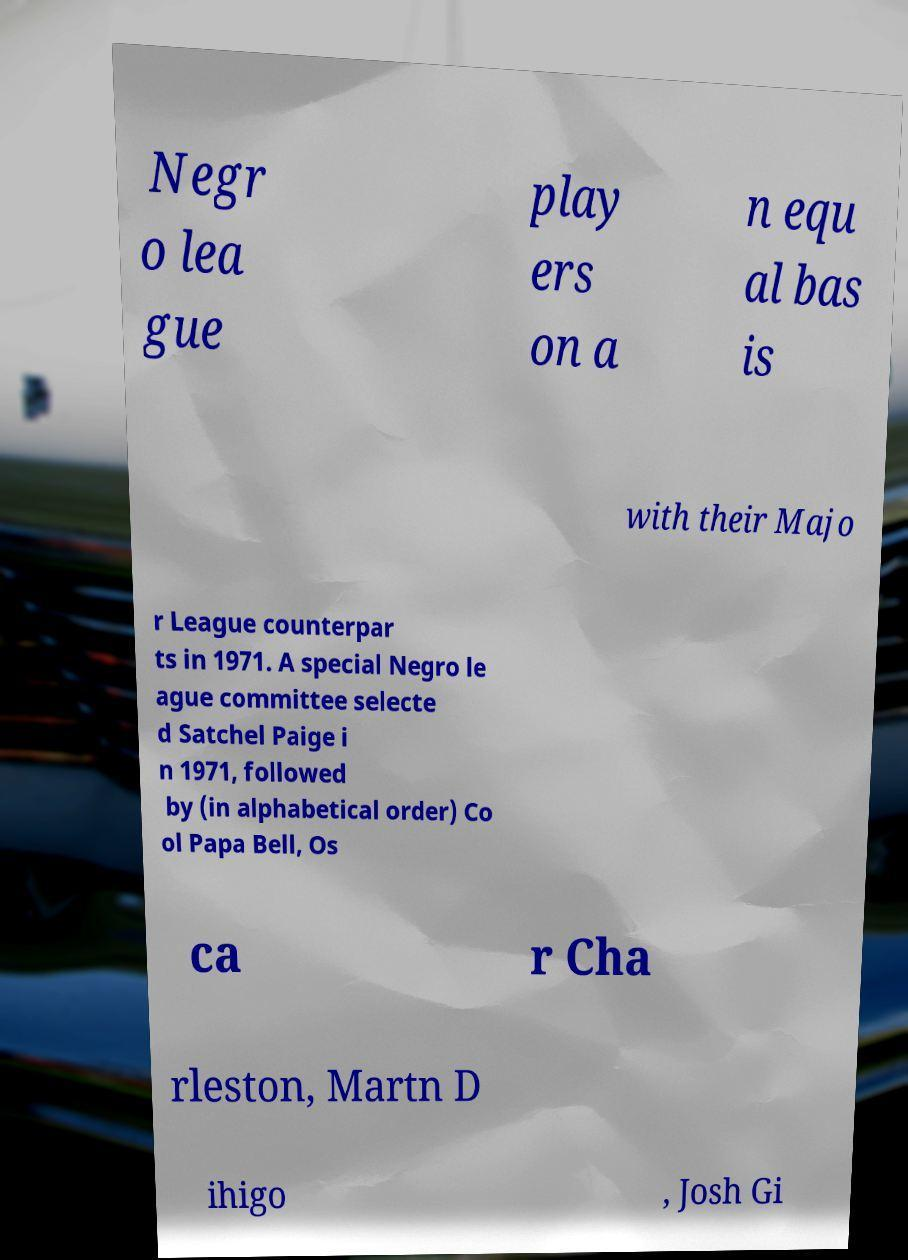For documentation purposes, I need the text within this image transcribed. Could you provide that? Negr o lea gue play ers on a n equ al bas is with their Majo r League counterpar ts in 1971. A special Negro le ague committee selecte d Satchel Paige i n 1971, followed by (in alphabetical order) Co ol Papa Bell, Os ca r Cha rleston, Martn D ihigo , Josh Gi 